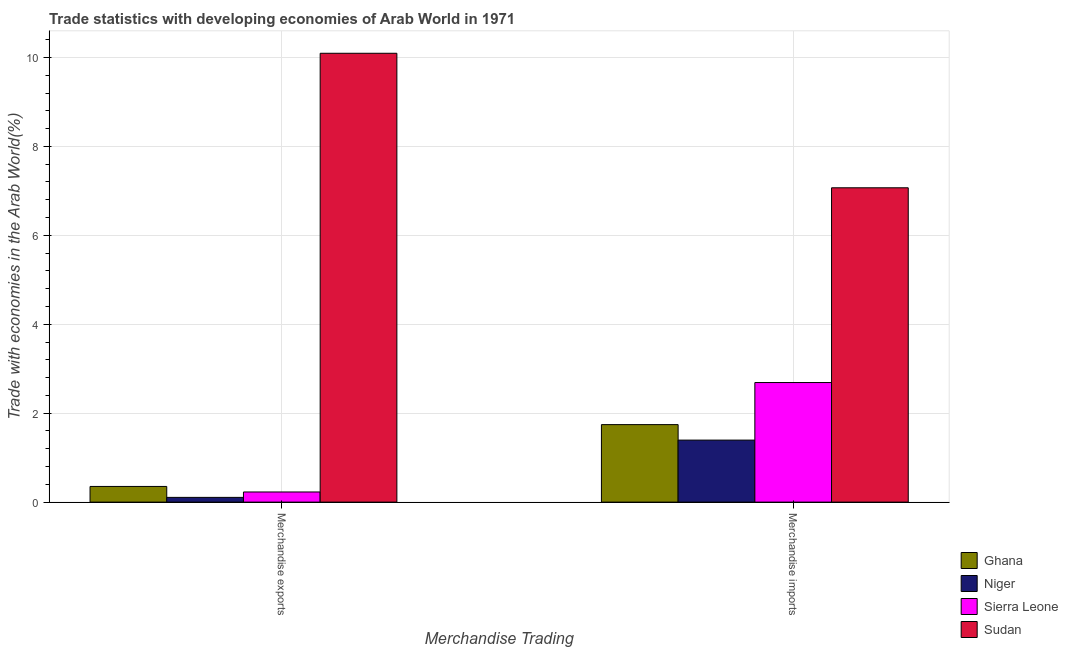How many groups of bars are there?
Your answer should be compact. 2. How many bars are there on the 2nd tick from the left?
Your answer should be very brief. 4. How many bars are there on the 2nd tick from the right?
Ensure brevity in your answer.  4. What is the merchandise imports in Niger?
Your answer should be compact. 1.39. Across all countries, what is the maximum merchandise exports?
Ensure brevity in your answer.  10.09. Across all countries, what is the minimum merchandise exports?
Offer a terse response. 0.11. In which country was the merchandise imports maximum?
Offer a very short reply. Sudan. In which country was the merchandise imports minimum?
Provide a succinct answer. Niger. What is the total merchandise imports in the graph?
Ensure brevity in your answer.  12.9. What is the difference between the merchandise exports in Sierra Leone and that in Niger?
Offer a terse response. 0.12. What is the difference between the merchandise imports in Ghana and the merchandise exports in Sierra Leone?
Your answer should be very brief. 1.51. What is the average merchandise imports per country?
Offer a very short reply. 3.22. What is the difference between the merchandise exports and merchandise imports in Sierra Leone?
Your answer should be very brief. -2.46. In how many countries, is the merchandise exports greater than 0.8 %?
Keep it short and to the point. 1. What is the ratio of the merchandise exports in Ghana to that in Niger?
Provide a short and direct response. 3.3. What does the 3rd bar from the left in Merchandise imports represents?
Ensure brevity in your answer.  Sierra Leone. What does the 4th bar from the right in Merchandise exports represents?
Your answer should be compact. Ghana. How many bars are there?
Provide a short and direct response. 8. What is the difference between two consecutive major ticks on the Y-axis?
Keep it short and to the point. 2. Does the graph contain any zero values?
Provide a succinct answer. No. Where does the legend appear in the graph?
Your answer should be very brief. Bottom right. How many legend labels are there?
Give a very brief answer. 4. How are the legend labels stacked?
Keep it short and to the point. Vertical. What is the title of the graph?
Provide a succinct answer. Trade statistics with developing economies of Arab World in 1971. Does "Sub-Saharan Africa (all income levels)" appear as one of the legend labels in the graph?
Your answer should be very brief. No. What is the label or title of the X-axis?
Give a very brief answer. Merchandise Trading. What is the label or title of the Y-axis?
Give a very brief answer. Trade with economies in the Arab World(%). What is the Trade with economies in the Arab World(%) in Ghana in Merchandise exports?
Offer a terse response. 0.35. What is the Trade with economies in the Arab World(%) in Niger in Merchandise exports?
Offer a very short reply. 0.11. What is the Trade with economies in the Arab World(%) in Sierra Leone in Merchandise exports?
Your answer should be compact. 0.23. What is the Trade with economies in the Arab World(%) in Sudan in Merchandise exports?
Provide a short and direct response. 10.09. What is the Trade with economies in the Arab World(%) of Ghana in Merchandise imports?
Your response must be concise. 1.74. What is the Trade with economies in the Arab World(%) in Niger in Merchandise imports?
Offer a terse response. 1.39. What is the Trade with economies in the Arab World(%) of Sierra Leone in Merchandise imports?
Provide a short and direct response. 2.69. What is the Trade with economies in the Arab World(%) in Sudan in Merchandise imports?
Ensure brevity in your answer.  7.07. Across all Merchandise Trading, what is the maximum Trade with economies in the Arab World(%) in Ghana?
Ensure brevity in your answer.  1.74. Across all Merchandise Trading, what is the maximum Trade with economies in the Arab World(%) in Niger?
Your response must be concise. 1.39. Across all Merchandise Trading, what is the maximum Trade with economies in the Arab World(%) in Sierra Leone?
Your answer should be very brief. 2.69. Across all Merchandise Trading, what is the maximum Trade with economies in the Arab World(%) in Sudan?
Offer a very short reply. 10.09. Across all Merchandise Trading, what is the minimum Trade with economies in the Arab World(%) in Ghana?
Offer a terse response. 0.35. Across all Merchandise Trading, what is the minimum Trade with economies in the Arab World(%) of Niger?
Your response must be concise. 0.11. Across all Merchandise Trading, what is the minimum Trade with economies in the Arab World(%) of Sierra Leone?
Offer a terse response. 0.23. Across all Merchandise Trading, what is the minimum Trade with economies in the Arab World(%) of Sudan?
Ensure brevity in your answer.  7.07. What is the total Trade with economies in the Arab World(%) in Ghana in the graph?
Your response must be concise. 2.1. What is the total Trade with economies in the Arab World(%) of Niger in the graph?
Ensure brevity in your answer.  1.5. What is the total Trade with economies in the Arab World(%) in Sierra Leone in the graph?
Keep it short and to the point. 2.92. What is the total Trade with economies in the Arab World(%) in Sudan in the graph?
Your response must be concise. 17.16. What is the difference between the Trade with economies in the Arab World(%) of Ghana in Merchandise exports and that in Merchandise imports?
Offer a very short reply. -1.39. What is the difference between the Trade with economies in the Arab World(%) in Niger in Merchandise exports and that in Merchandise imports?
Give a very brief answer. -1.29. What is the difference between the Trade with economies in the Arab World(%) in Sierra Leone in Merchandise exports and that in Merchandise imports?
Make the answer very short. -2.46. What is the difference between the Trade with economies in the Arab World(%) of Sudan in Merchandise exports and that in Merchandise imports?
Provide a short and direct response. 3.03. What is the difference between the Trade with economies in the Arab World(%) in Ghana in Merchandise exports and the Trade with economies in the Arab World(%) in Niger in Merchandise imports?
Provide a short and direct response. -1.04. What is the difference between the Trade with economies in the Arab World(%) in Ghana in Merchandise exports and the Trade with economies in the Arab World(%) in Sierra Leone in Merchandise imports?
Provide a short and direct response. -2.34. What is the difference between the Trade with economies in the Arab World(%) of Ghana in Merchandise exports and the Trade with economies in the Arab World(%) of Sudan in Merchandise imports?
Ensure brevity in your answer.  -6.72. What is the difference between the Trade with economies in the Arab World(%) of Niger in Merchandise exports and the Trade with economies in the Arab World(%) of Sierra Leone in Merchandise imports?
Give a very brief answer. -2.58. What is the difference between the Trade with economies in the Arab World(%) in Niger in Merchandise exports and the Trade with economies in the Arab World(%) in Sudan in Merchandise imports?
Your answer should be compact. -6.96. What is the difference between the Trade with economies in the Arab World(%) of Sierra Leone in Merchandise exports and the Trade with economies in the Arab World(%) of Sudan in Merchandise imports?
Make the answer very short. -6.84. What is the average Trade with economies in the Arab World(%) of Ghana per Merchandise Trading?
Your answer should be very brief. 1.05. What is the average Trade with economies in the Arab World(%) of Niger per Merchandise Trading?
Make the answer very short. 0.75. What is the average Trade with economies in the Arab World(%) of Sierra Leone per Merchandise Trading?
Make the answer very short. 1.46. What is the average Trade with economies in the Arab World(%) in Sudan per Merchandise Trading?
Offer a very short reply. 8.58. What is the difference between the Trade with economies in the Arab World(%) of Ghana and Trade with economies in the Arab World(%) of Niger in Merchandise exports?
Your answer should be compact. 0.25. What is the difference between the Trade with economies in the Arab World(%) in Ghana and Trade with economies in the Arab World(%) in Sierra Leone in Merchandise exports?
Offer a very short reply. 0.12. What is the difference between the Trade with economies in the Arab World(%) in Ghana and Trade with economies in the Arab World(%) in Sudan in Merchandise exports?
Keep it short and to the point. -9.74. What is the difference between the Trade with economies in the Arab World(%) in Niger and Trade with economies in the Arab World(%) in Sierra Leone in Merchandise exports?
Provide a short and direct response. -0.12. What is the difference between the Trade with economies in the Arab World(%) in Niger and Trade with economies in the Arab World(%) in Sudan in Merchandise exports?
Make the answer very short. -9.99. What is the difference between the Trade with economies in the Arab World(%) in Sierra Leone and Trade with economies in the Arab World(%) in Sudan in Merchandise exports?
Your answer should be compact. -9.87. What is the difference between the Trade with economies in the Arab World(%) of Ghana and Trade with economies in the Arab World(%) of Niger in Merchandise imports?
Provide a short and direct response. 0.35. What is the difference between the Trade with economies in the Arab World(%) in Ghana and Trade with economies in the Arab World(%) in Sierra Leone in Merchandise imports?
Provide a succinct answer. -0.95. What is the difference between the Trade with economies in the Arab World(%) in Ghana and Trade with economies in the Arab World(%) in Sudan in Merchandise imports?
Your response must be concise. -5.33. What is the difference between the Trade with economies in the Arab World(%) in Niger and Trade with economies in the Arab World(%) in Sierra Leone in Merchandise imports?
Provide a succinct answer. -1.29. What is the difference between the Trade with economies in the Arab World(%) in Niger and Trade with economies in the Arab World(%) in Sudan in Merchandise imports?
Your response must be concise. -5.67. What is the difference between the Trade with economies in the Arab World(%) in Sierra Leone and Trade with economies in the Arab World(%) in Sudan in Merchandise imports?
Keep it short and to the point. -4.38. What is the ratio of the Trade with economies in the Arab World(%) of Ghana in Merchandise exports to that in Merchandise imports?
Offer a terse response. 0.2. What is the ratio of the Trade with economies in the Arab World(%) in Niger in Merchandise exports to that in Merchandise imports?
Keep it short and to the point. 0.08. What is the ratio of the Trade with economies in the Arab World(%) in Sierra Leone in Merchandise exports to that in Merchandise imports?
Provide a short and direct response. 0.08. What is the ratio of the Trade with economies in the Arab World(%) of Sudan in Merchandise exports to that in Merchandise imports?
Ensure brevity in your answer.  1.43. What is the difference between the highest and the second highest Trade with economies in the Arab World(%) in Ghana?
Your answer should be compact. 1.39. What is the difference between the highest and the second highest Trade with economies in the Arab World(%) of Niger?
Offer a terse response. 1.29. What is the difference between the highest and the second highest Trade with economies in the Arab World(%) of Sierra Leone?
Offer a terse response. 2.46. What is the difference between the highest and the second highest Trade with economies in the Arab World(%) in Sudan?
Provide a succinct answer. 3.03. What is the difference between the highest and the lowest Trade with economies in the Arab World(%) of Ghana?
Your response must be concise. 1.39. What is the difference between the highest and the lowest Trade with economies in the Arab World(%) in Niger?
Keep it short and to the point. 1.29. What is the difference between the highest and the lowest Trade with economies in the Arab World(%) of Sierra Leone?
Your response must be concise. 2.46. What is the difference between the highest and the lowest Trade with economies in the Arab World(%) of Sudan?
Your answer should be very brief. 3.03. 